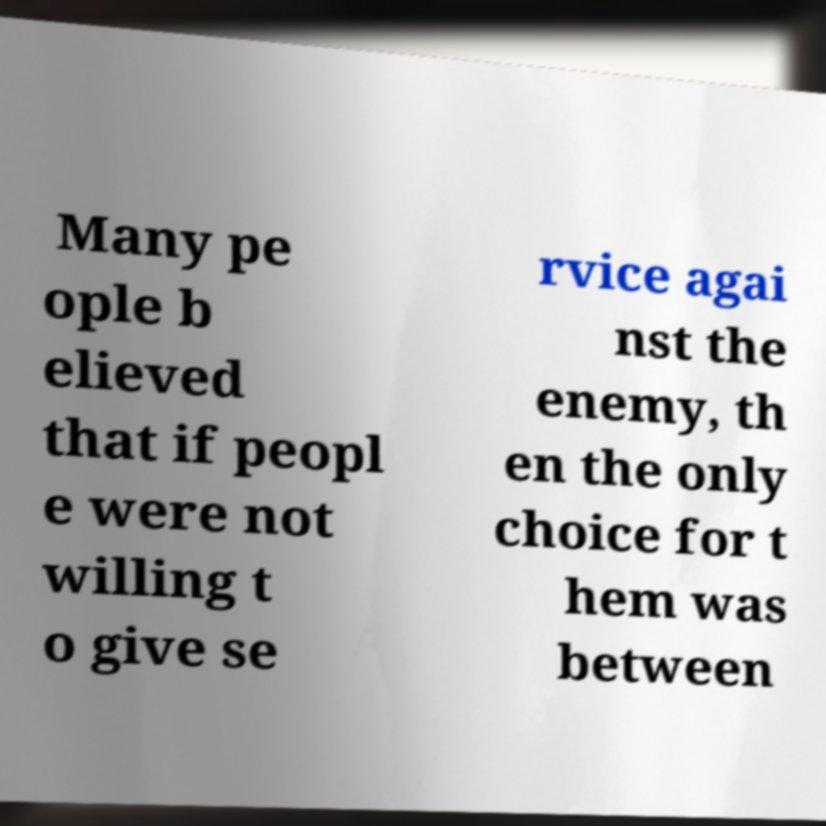Could you assist in decoding the text presented in this image and type it out clearly? Many pe ople b elieved that if peopl e were not willing t o give se rvice agai nst the enemy, th en the only choice for t hem was between 